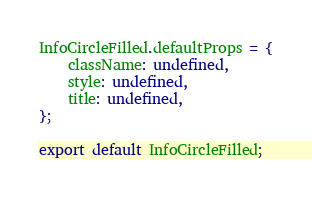Convert code to text. <code><loc_0><loc_0><loc_500><loc_500><_JavaScript_>InfoCircleFilled.defaultProps = {
    className: undefined,
    style: undefined,
    title: undefined,
};

export default InfoCircleFilled;
</code> 